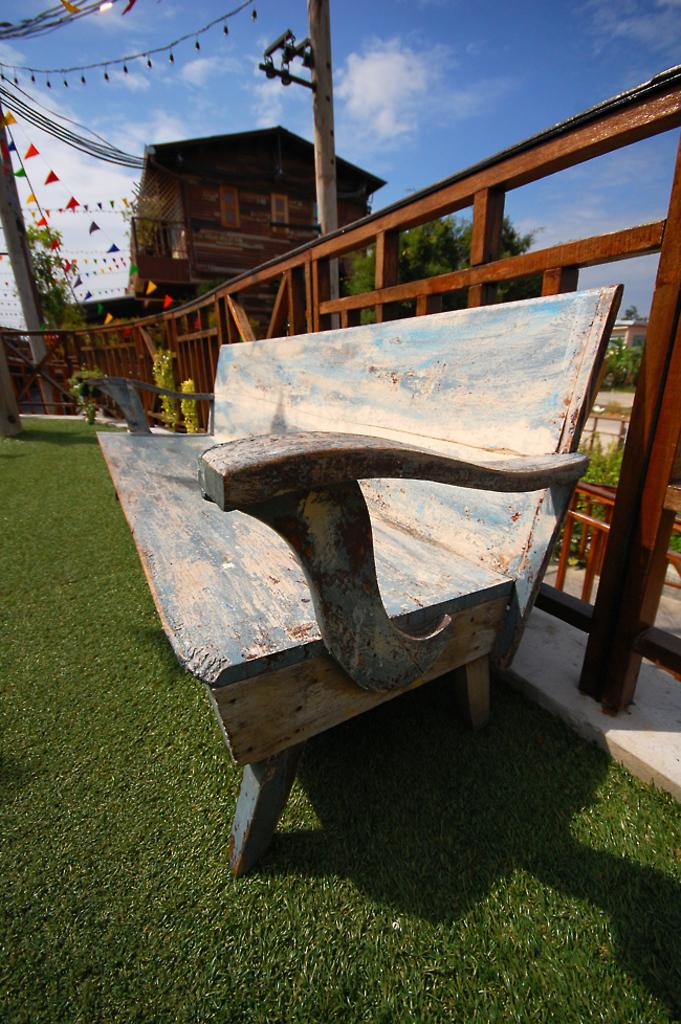What is located in the center of the image? There is a bench in the center of the image. Where is the bench situated? The bench is on the grass. What can be seen in the background of the image? There are poles, wooden fencing, a building, trees, and the sky visible in the background of the image. What is the condition of the sky in the image? The sky is visible in the background of the image, and there are clouds present. What type of underwear is hanging on the wooden fencing in the image? There is no underwear present in the image; it features a bench on the grass with various background elements. Can you tell me how many mailboxes are visible in the image? There are no mailboxes visible in the image. 